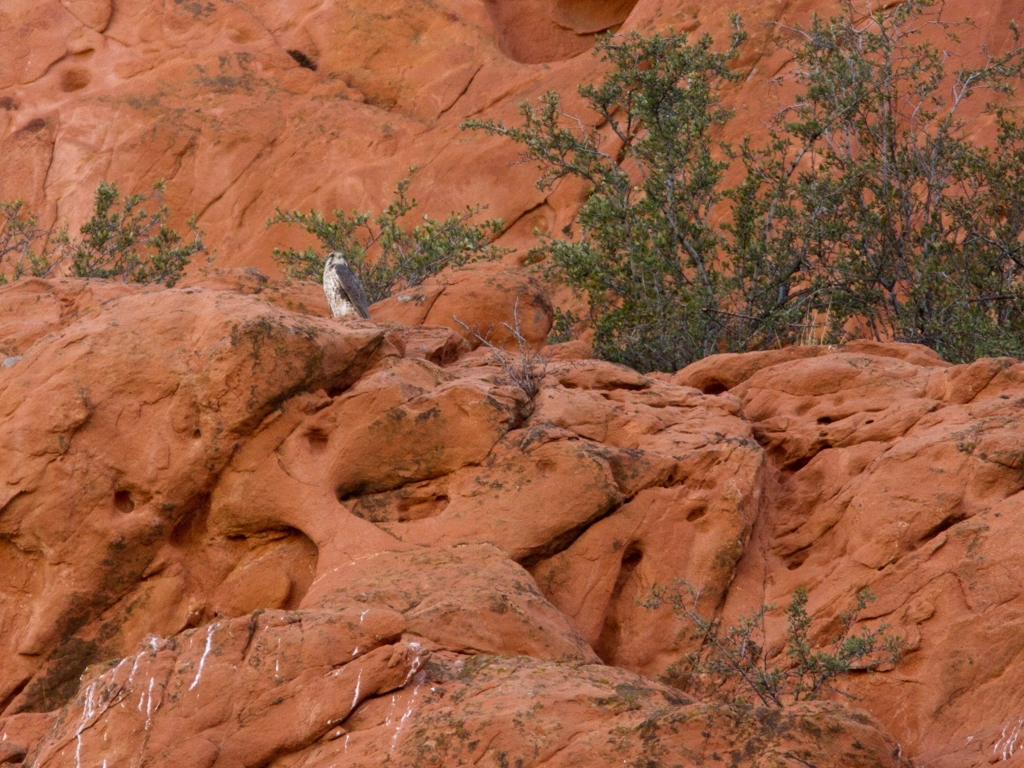This area seems remote. What challenges might humans face if they tried to live here? Living in such a remote and arid environment poses several challenges. Access to fresh water could be scarce, extreme temperatures can be difficult to endure, and the terrain may limit agriculture and transportation. Adaptation to these conditions would require planning and sustainable resource management. 